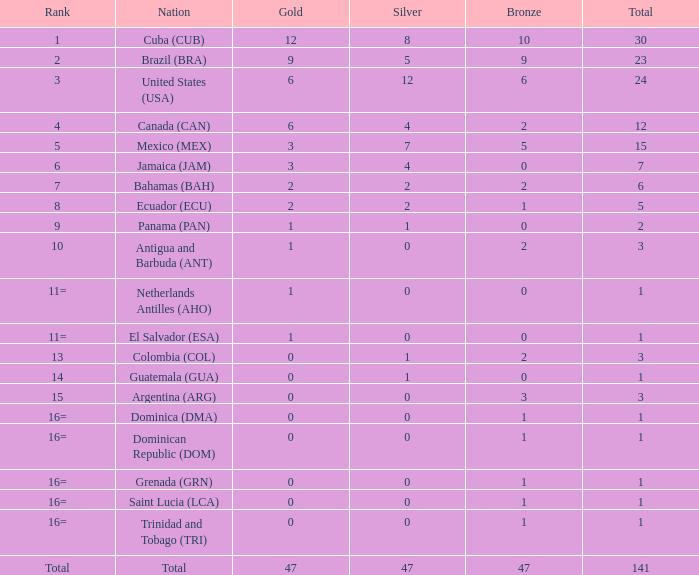What is the average silver with more than 0 gold, a Rank of 1, and a Total smaller than 30? None. 